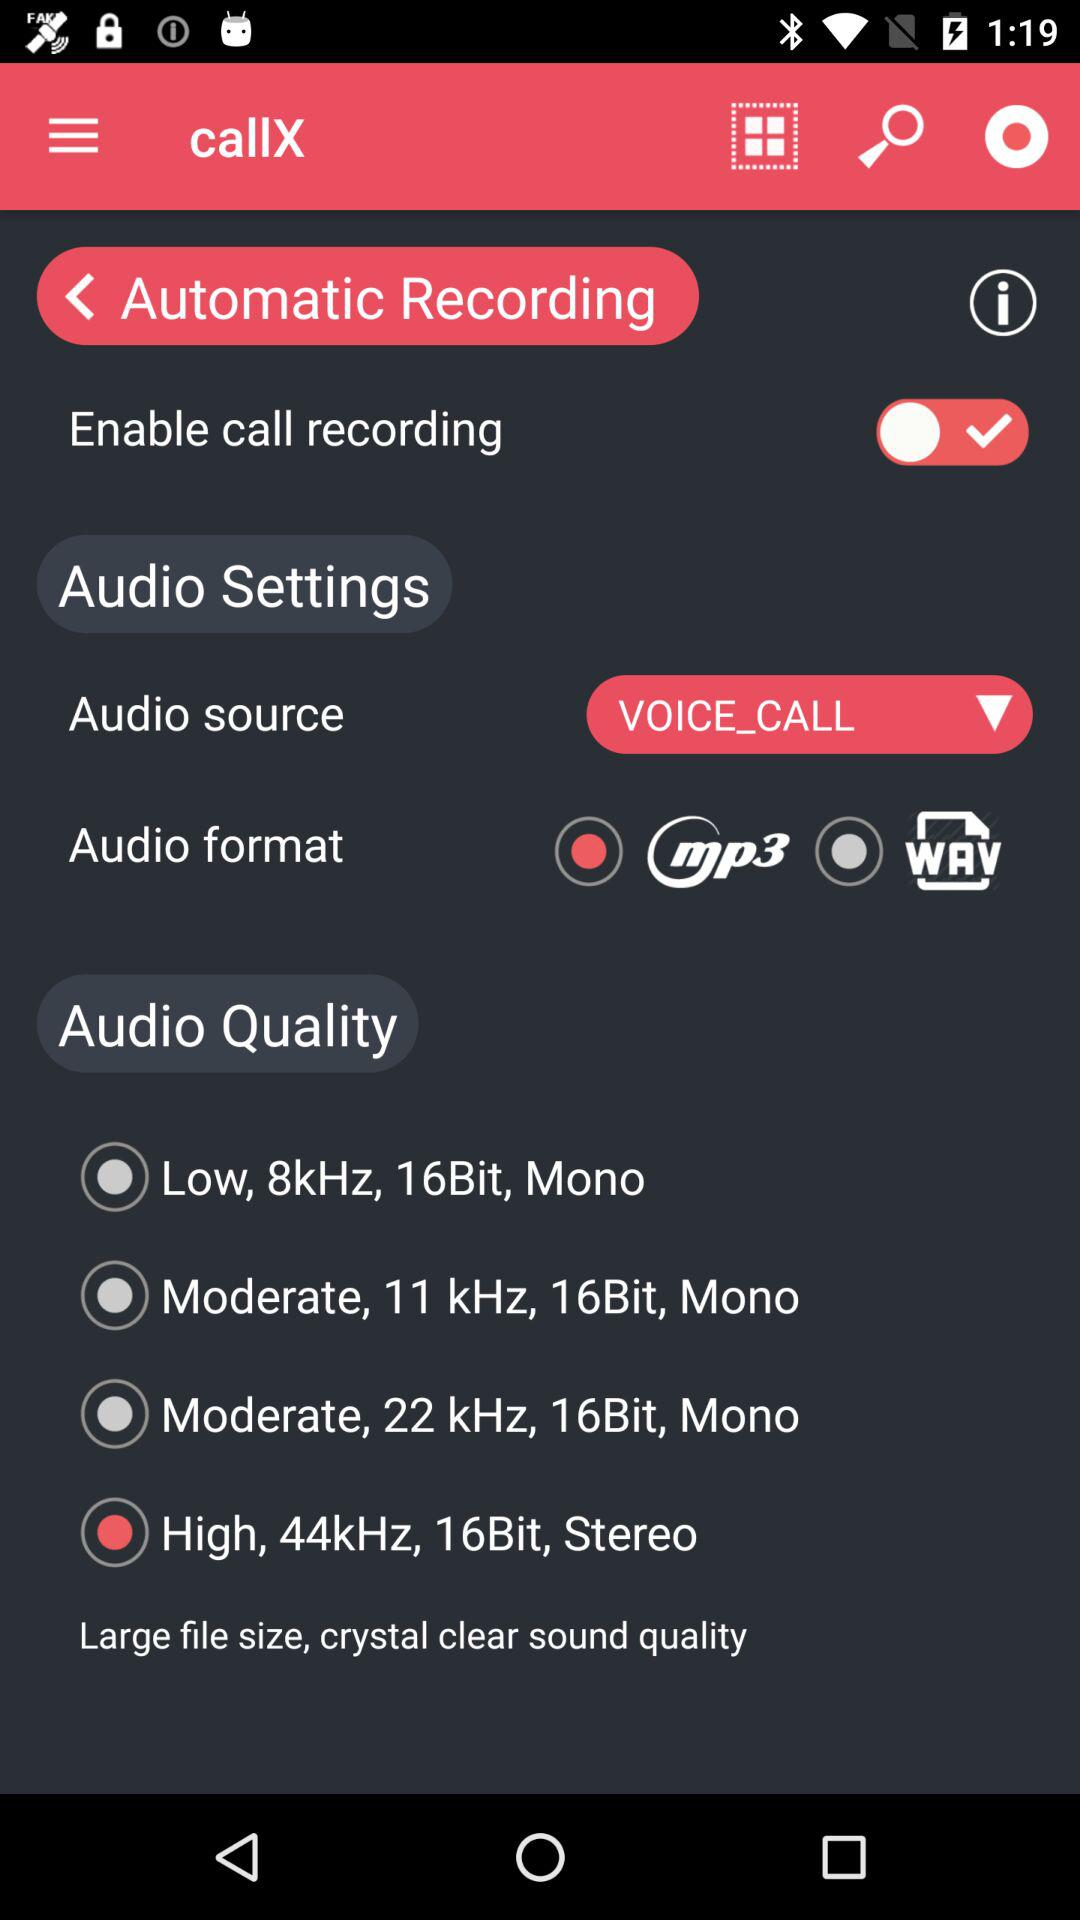What is the audio source? The audio source is "VOICE_CALL". 